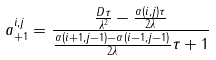Convert formula to latex. <formula><loc_0><loc_0><loc_500><loc_500>a _ { + 1 } ^ { i , j } = \frac { \frac { D \tau } { \lambda ^ { 2 } } - \frac { \alpha ( i , j ) \tau } { 2 \lambda } } { \frac { \alpha ( i + 1 , j - 1 ) - \alpha ( i - 1 , j - 1 ) } { 2 \lambda } \tau + 1 }</formula> 